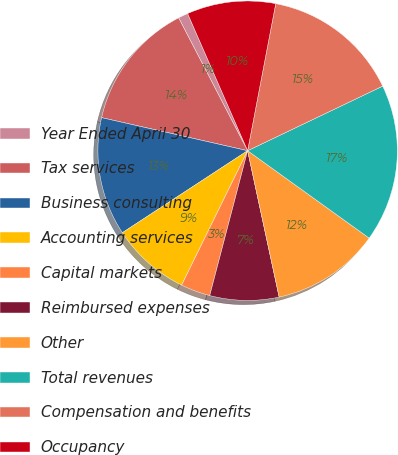Convert chart to OTSL. <chart><loc_0><loc_0><loc_500><loc_500><pie_chart><fcel>Year Ended April 30<fcel>Tax services<fcel>Business consulting<fcel>Accounting services<fcel>Capital markets<fcel>Reimbursed expenses<fcel>Other<fcel>Total revenues<fcel>Compensation and benefits<fcel>Occupancy<nl><fcel>1.06%<fcel>13.83%<fcel>12.77%<fcel>8.51%<fcel>3.19%<fcel>7.45%<fcel>11.7%<fcel>17.02%<fcel>14.89%<fcel>9.57%<nl></chart> 